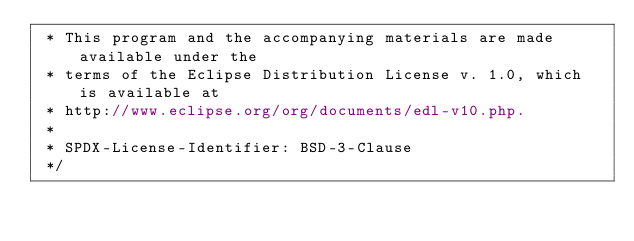<code> <loc_0><loc_0><loc_500><loc_500><_Java_> * This program and the accompanying materials are made available under the
 * terms of the Eclipse Distribution License v. 1.0, which is available at
 * http://www.eclipse.org/org/documents/edl-v10.php.
 *
 * SPDX-License-Identifier: BSD-3-Clause
 */
</code> 